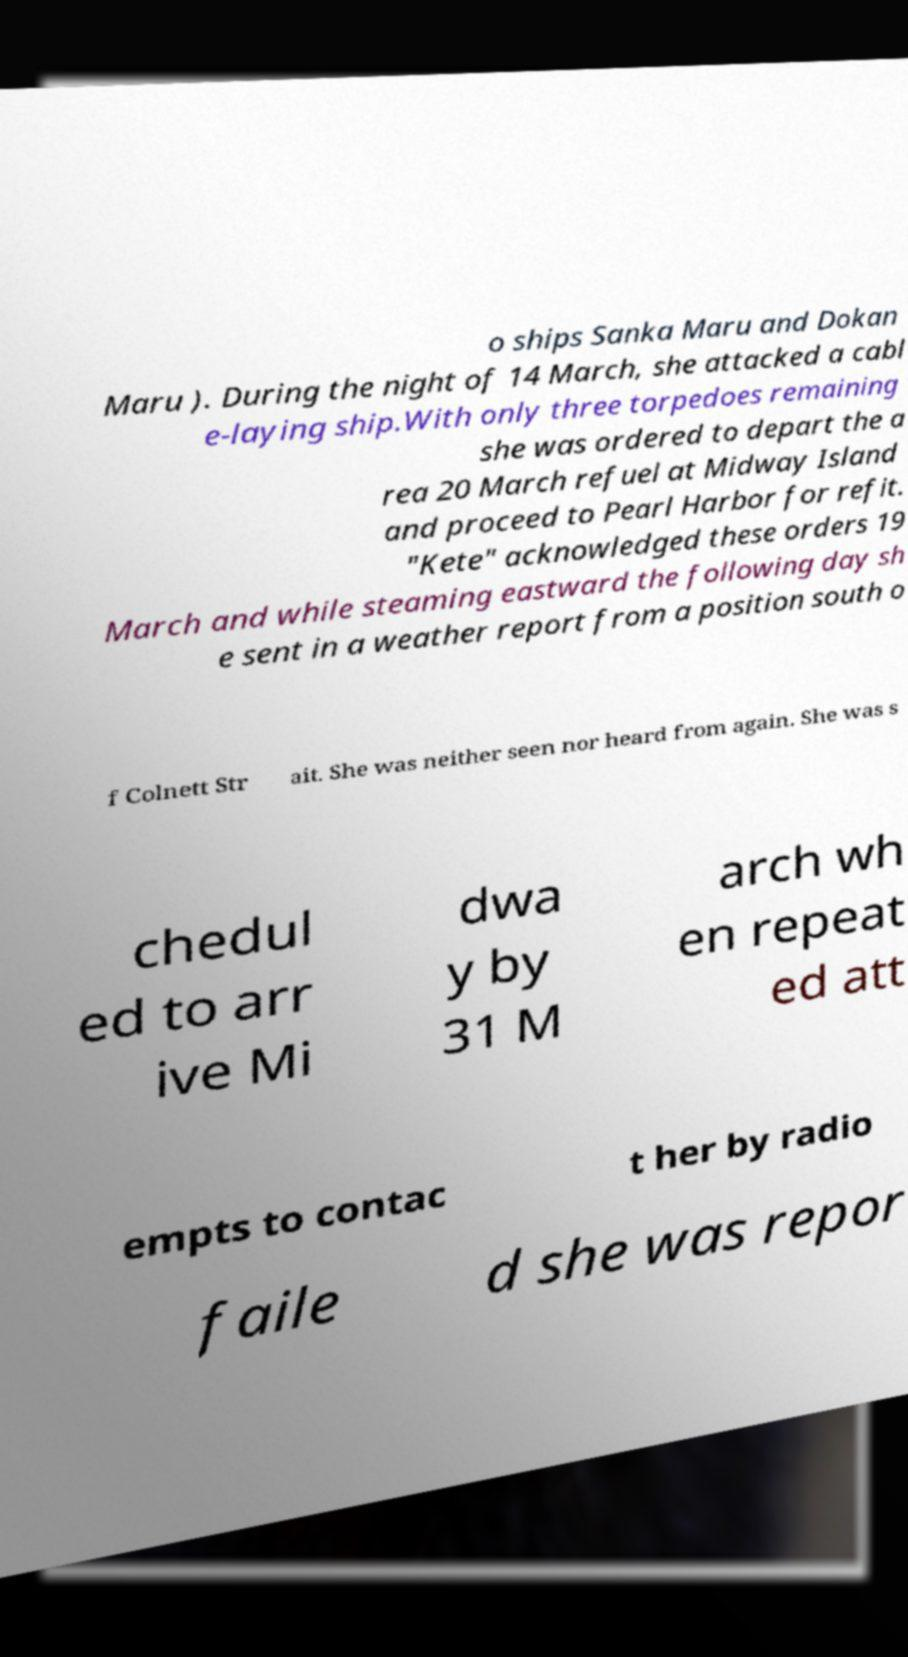Could you extract and type out the text from this image? o ships Sanka Maru and Dokan Maru ). During the night of 14 March, she attacked a cabl e-laying ship.With only three torpedoes remaining she was ordered to depart the a rea 20 March refuel at Midway Island and proceed to Pearl Harbor for refit. "Kete" acknowledged these orders 19 March and while steaming eastward the following day sh e sent in a weather report from a position south o f Colnett Str ait. She was neither seen nor heard from again. She was s chedul ed to arr ive Mi dwa y by 31 M arch wh en repeat ed att empts to contac t her by radio faile d she was repor 